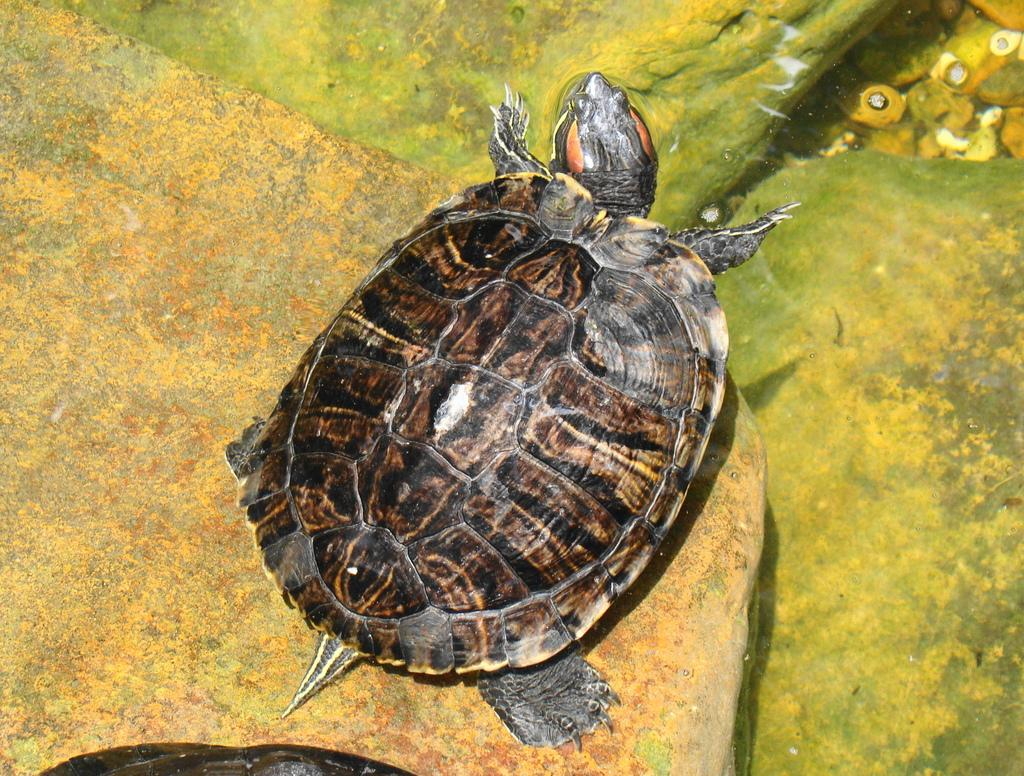What animal can be seen in the image? There is a turtle in the image. Where is the turtle located? The turtle is on a rock. What can be seen in the background of the image? There is water visible in the image. What is the color of the turtle? The turtle is black in color. Can you see a ghost walking on the water in the image? No, there is no ghost or any indication of a ghost walking on the water in the image. 